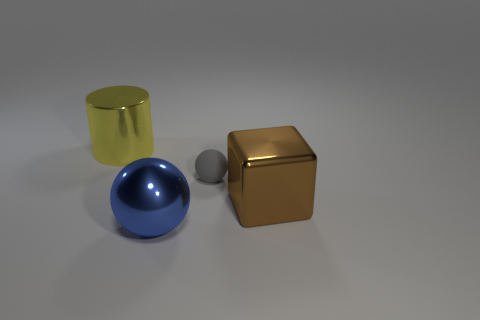Are there any objects that might indicate the size scale of the scene? No specific objects indicate the precise scale, but the relative size of the objects to each other suggests they could be common household items, such as a cup or ball. Can you provide an estimation of their sizes based on that assumption? If we assume they are typical household items, the cylinder might be similar in size to a cup, around 10 centimeters tall, and the cube could be akin to a small box, roughly 15 centimeters on each side. 